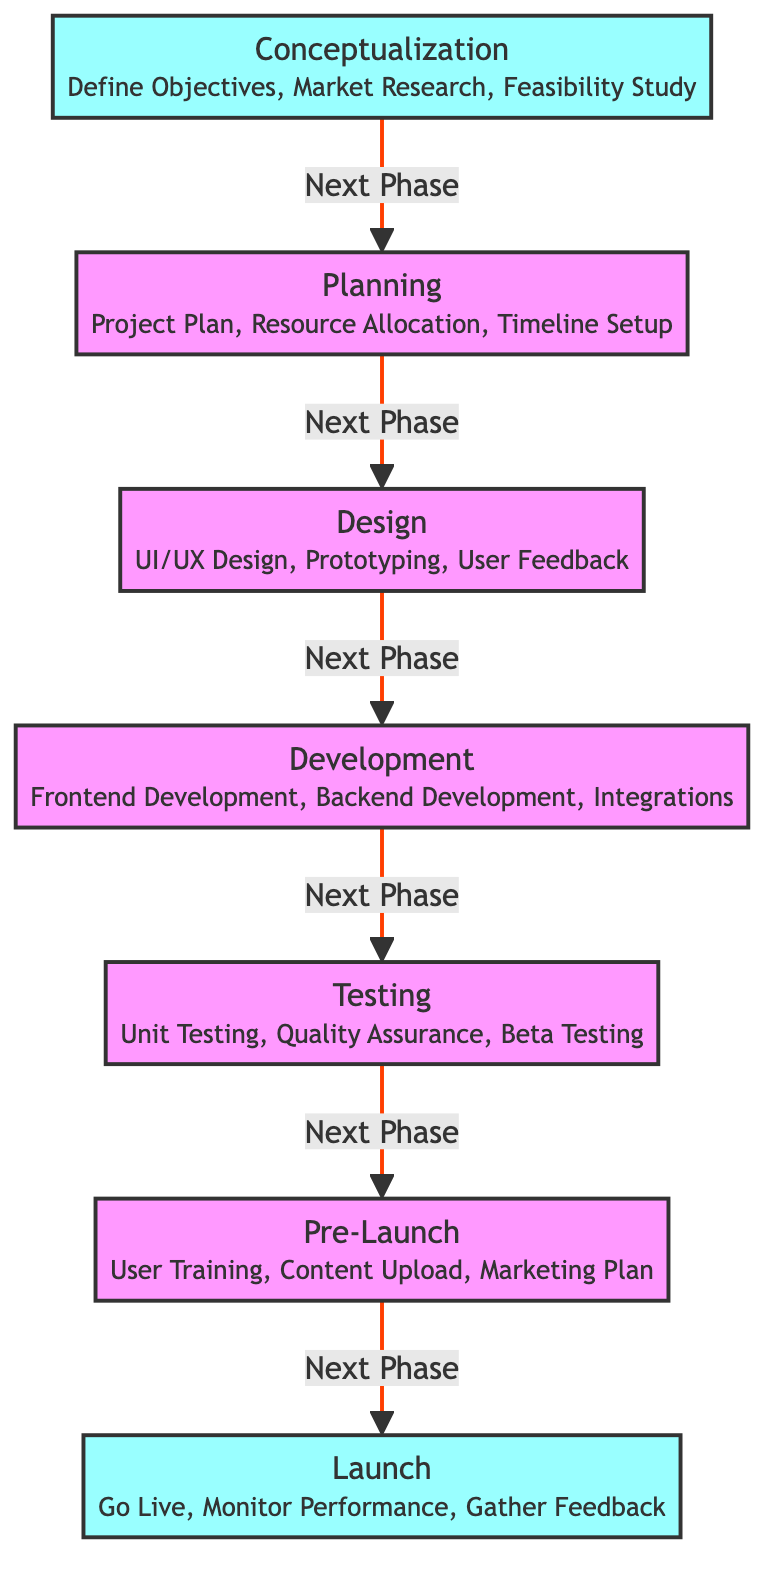What is the first milestone in the development timeline? The first milestone in the timeline is "Conceptualization," which is depicted as a node at the start of the flowchart.
Answer: Conceptualization How many phases are there from Conceptualization to Launch? Counting the nodes starting from "Conceptualization" to "Launch," there are a total of six phases.
Answer: 6 What is the relationship between Testing and Pre-Launch phases? The arrow indicates that Testing leads to Pre-Launch, showing a sequential relationship where Testing precedes Pre-Launch.
Answer: Next Phase What does the Design phase involve? The Design phase is described with details including "UI/UX Design, Prototyping, User Feedback," which are key activities in this phase.
Answer: UI/UX Design, Prototyping, User Feedback Which phase comes directly after Development? The flowchart shows that Testing follows Development, indicating that these two phases are sequential.
Answer: Testing What phase includes Monitoring Performance? The "Launch" phase encompasses "Monitor Performance," indicating that this activity is part of the Launch stage of the project.
Answer: Launch How is the relationship between Planning and Development represented? The relationship is shown with an arrow leading from Planning to Development, signifying that Development follows Planning in the project timeline.
Answer: Next Phase Which milestone is designated with a unique style in the diagram? The diagram indicates that both "Conceptualization" and "Launch" milestones are highlighted with a distinct class for milestones, setting them apart from other phases.
Answer: Conceptualization, Launch What type of testing occurs in the Testing phase? The Testing phase emphasizes "Unit Testing, Quality Assurance, Beta Testing," showcasing several forms of testing that are critical before launch.
Answer: Unit Testing, Quality Assurance, Beta Testing 